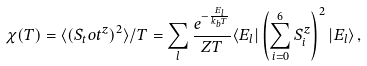Convert formula to latex. <formula><loc_0><loc_0><loc_500><loc_500>\chi ( T ) = \langle ( S _ { t } o t ^ { z } ) ^ { 2 } \rangle / T = \sum _ { l } \frac { e ^ { - \frac { E _ { l } } { k _ { b } T } } } { Z T } \langle E _ { l } | \left ( \sum _ { i = 0 } ^ { 6 } S _ { i } ^ { z } \right ) ^ { 2 } | E _ { l } \rangle \, ,</formula> 